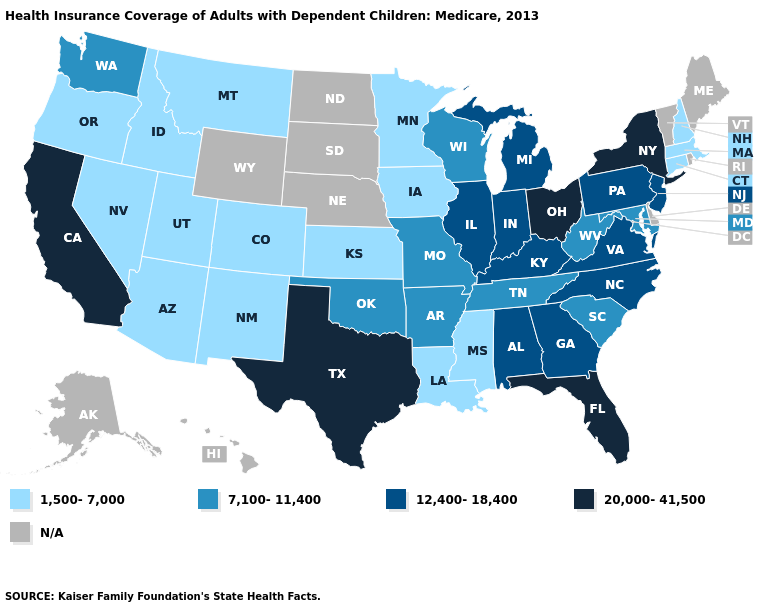What is the lowest value in the USA?
Write a very short answer. 1,500-7,000. Does Arizona have the lowest value in the USA?
Be succinct. Yes. Name the states that have a value in the range 1,500-7,000?
Keep it brief. Arizona, Colorado, Connecticut, Idaho, Iowa, Kansas, Louisiana, Massachusetts, Minnesota, Mississippi, Montana, Nevada, New Hampshire, New Mexico, Oregon, Utah. What is the value of North Dakota?
Give a very brief answer. N/A. What is the lowest value in the USA?
Write a very short answer. 1,500-7,000. What is the value of Virginia?
Concise answer only. 12,400-18,400. Name the states that have a value in the range N/A?
Quick response, please. Alaska, Delaware, Hawaii, Maine, Nebraska, North Dakota, Rhode Island, South Dakota, Vermont, Wyoming. Does Louisiana have the lowest value in the South?
Write a very short answer. Yes. Does Ohio have the highest value in the USA?
Quick response, please. Yes. Does the first symbol in the legend represent the smallest category?
Keep it brief. Yes. Does the first symbol in the legend represent the smallest category?
Write a very short answer. Yes. What is the highest value in the South ?
Short answer required. 20,000-41,500. 